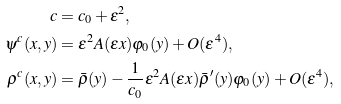<formula> <loc_0><loc_0><loc_500><loc_500>c & = c _ { 0 } + \varepsilon ^ { 2 } , \\ \psi ^ { c } ( x , y ) & = \varepsilon ^ { 2 } A ( \varepsilon x ) \varphi _ { 0 } ( y ) + O ( \varepsilon ^ { 4 } ) , \\ \rho ^ { c } ( x , y ) & = \bar { \rho } ( y ) - \frac { 1 } { c _ { 0 } } \varepsilon ^ { 2 } A ( \varepsilon x ) \bar { \rho } ^ { \prime } ( y ) \varphi _ { 0 } ( y ) + O ( \varepsilon ^ { 4 } ) ,</formula> 